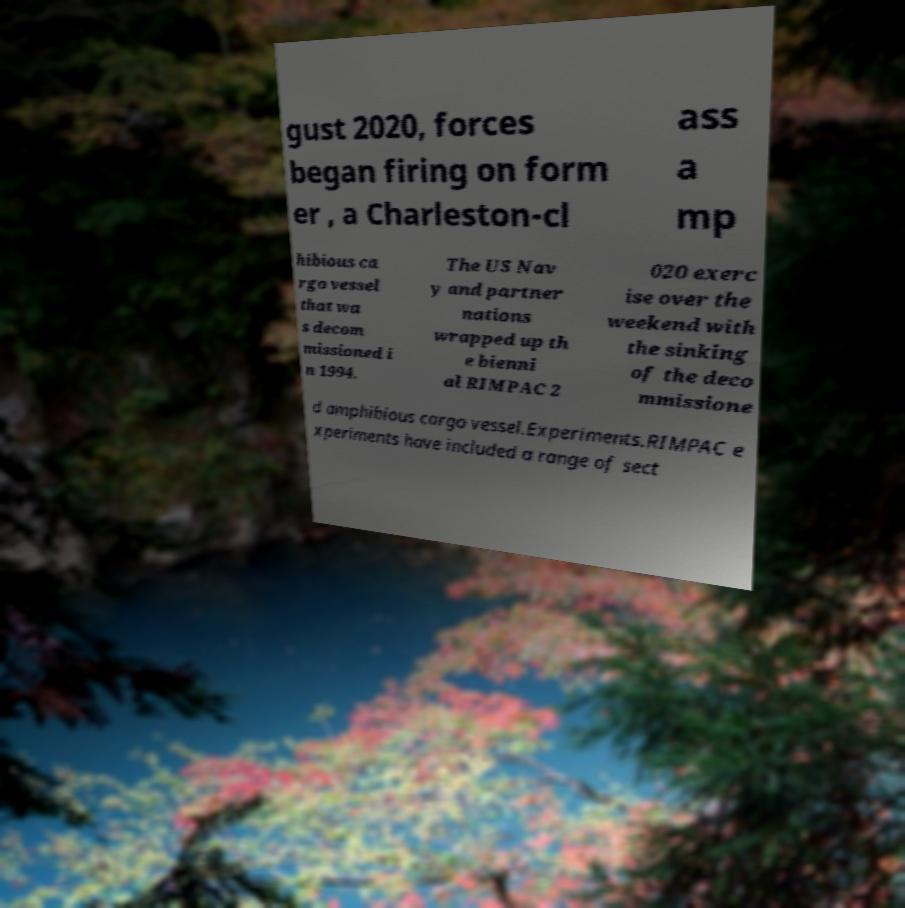Could you assist in decoding the text presented in this image and type it out clearly? gust 2020, forces began firing on form er , a Charleston-cl ass a mp hibious ca rgo vessel that wa s decom missioned i n 1994. The US Nav y and partner nations wrapped up th e bienni al RIMPAC 2 020 exerc ise over the weekend with the sinking of the deco mmissione d amphibious cargo vessel.Experiments.RIMPAC e xperiments have included a range of sect 